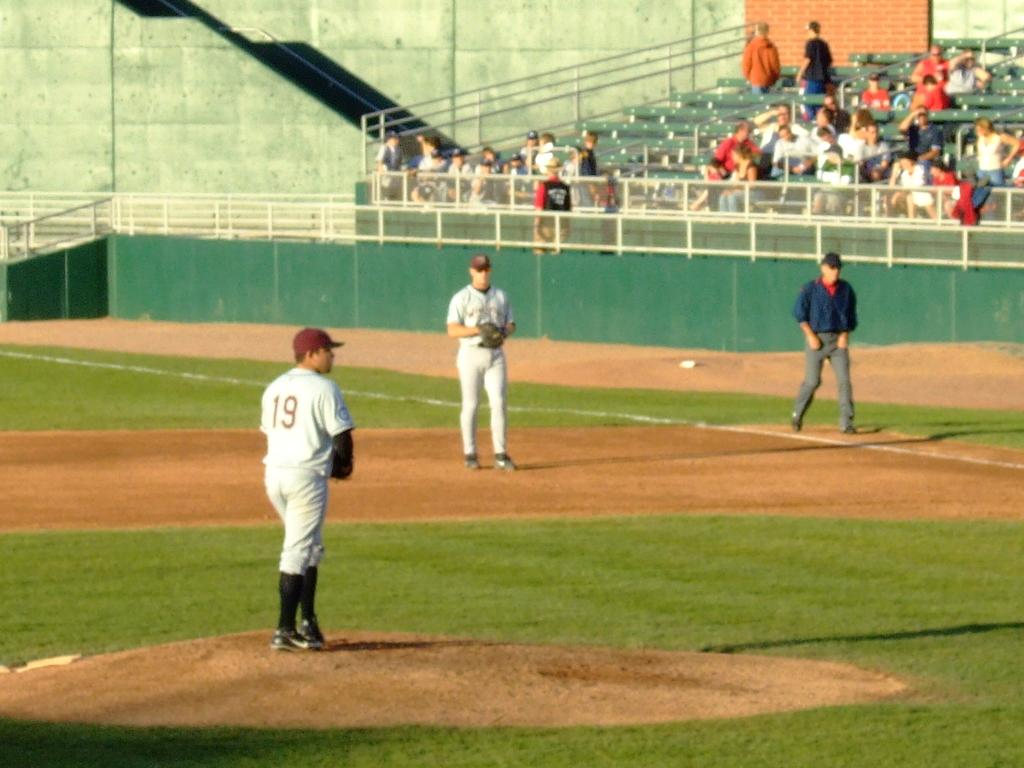<image>
Relay a brief, clear account of the picture shown. The pitcher is standing on the mound wearing number 19 